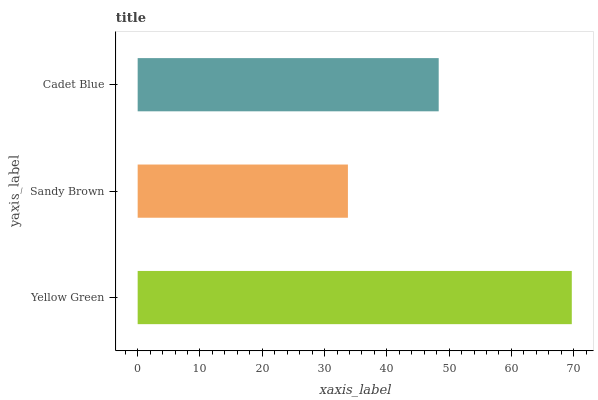Is Sandy Brown the minimum?
Answer yes or no. Yes. Is Yellow Green the maximum?
Answer yes or no. Yes. Is Cadet Blue the minimum?
Answer yes or no. No. Is Cadet Blue the maximum?
Answer yes or no. No. Is Cadet Blue greater than Sandy Brown?
Answer yes or no. Yes. Is Sandy Brown less than Cadet Blue?
Answer yes or no. Yes. Is Sandy Brown greater than Cadet Blue?
Answer yes or no. No. Is Cadet Blue less than Sandy Brown?
Answer yes or no. No. Is Cadet Blue the high median?
Answer yes or no. Yes. Is Cadet Blue the low median?
Answer yes or no. Yes. Is Yellow Green the high median?
Answer yes or no. No. Is Sandy Brown the low median?
Answer yes or no. No. 